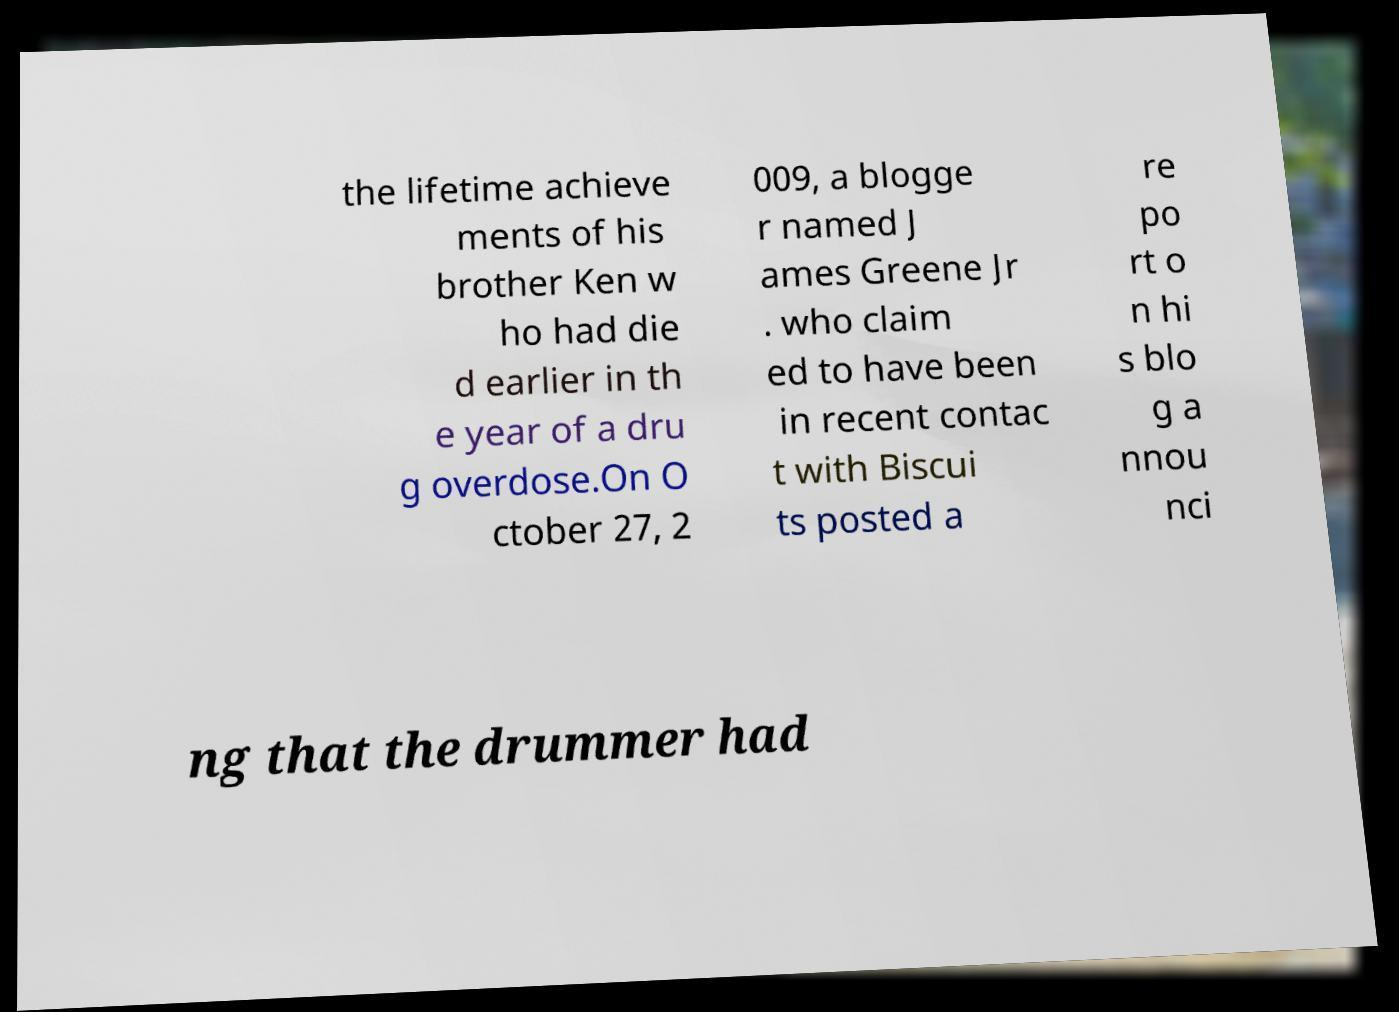What messages or text are displayed in this image? I need them in a readable, typed format. the lifetime achieve ments of his brother Ken w ho had die d earlier in th e year of a dru g overdose.On O ctober 27, 2 009, a blogge r named J ames Greene Jr . who claim ed to have been in recent contac t with Biscui ts posted a re po rt o n hi s blo g a nnou nci ng that the drummer had 